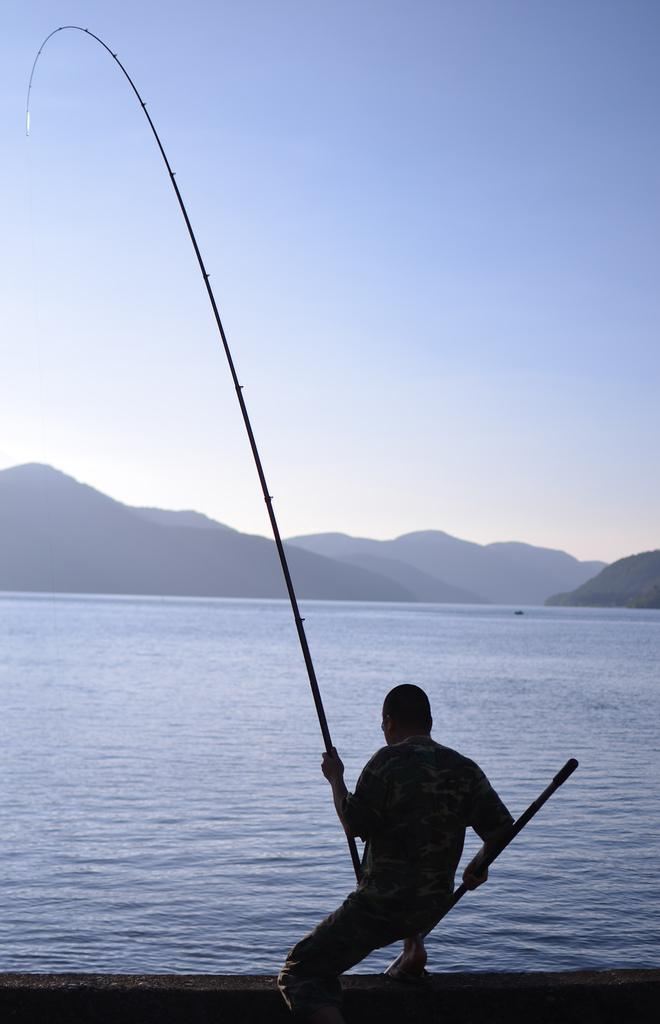What is the main subject in the foreground of the picture? There is a person in the foreground of the picture. What is the person holding in the picture? The person is holding a fishing net. What can be seen in the middle of the picture? There are hills and a water body in the middle of the picture. What is visible at the top of the picture? The sky is visible at the top of the picture. What type of memory is being exchanged between the person and the hills in the picture? There is no memory exchange depicted in the image; it features a person holding a fishing net, hills, a water body, and the sky. 